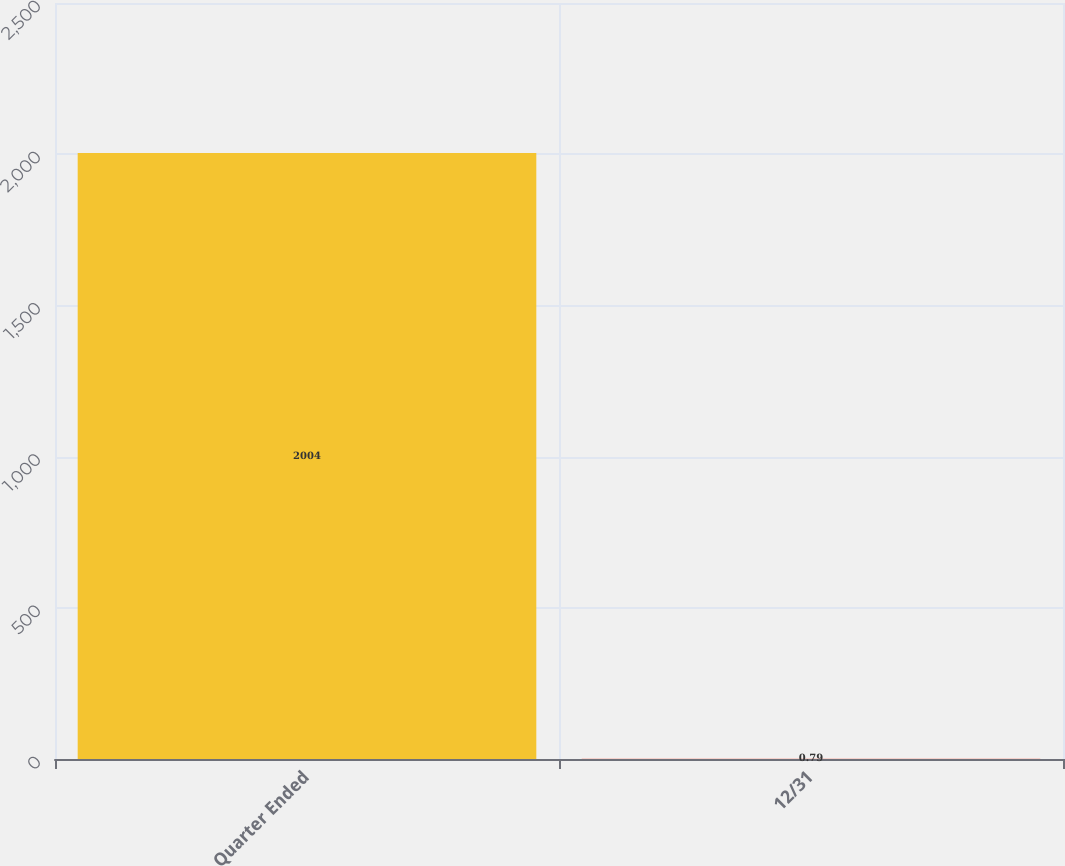<chart> <loc_0><loc_0><loc_500><loc_500><bar_chart><fcel>Quarter Ended<fcel>12/31<nl><fcel>2004<fcel>0.79<nl></chart> 